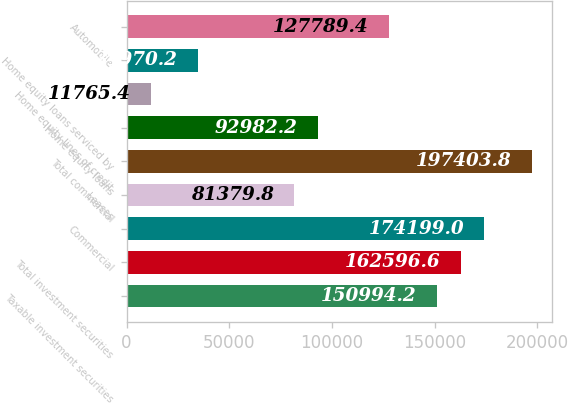Convert chart to OTSL. <chart><loc_0><loc_0><loc_500><loc_500><bar_chart><fcel>Taxable investment securities<fcel>Total investment securities<fcel>Commercial<fcel>Leases<fcel>Total commercial<fcel>Home equity loans<fcel>Home equity lines of credit<fcel>Home equity loans serviced by<fcel>Automobile<nl><fcel>150994<fcel>162597<fcel>174199<fcel>81379.8<fcel>197404<fcel>92982.2<fcel>11765.4<fcel>34970.2<fcel>127789<nl></chart> 